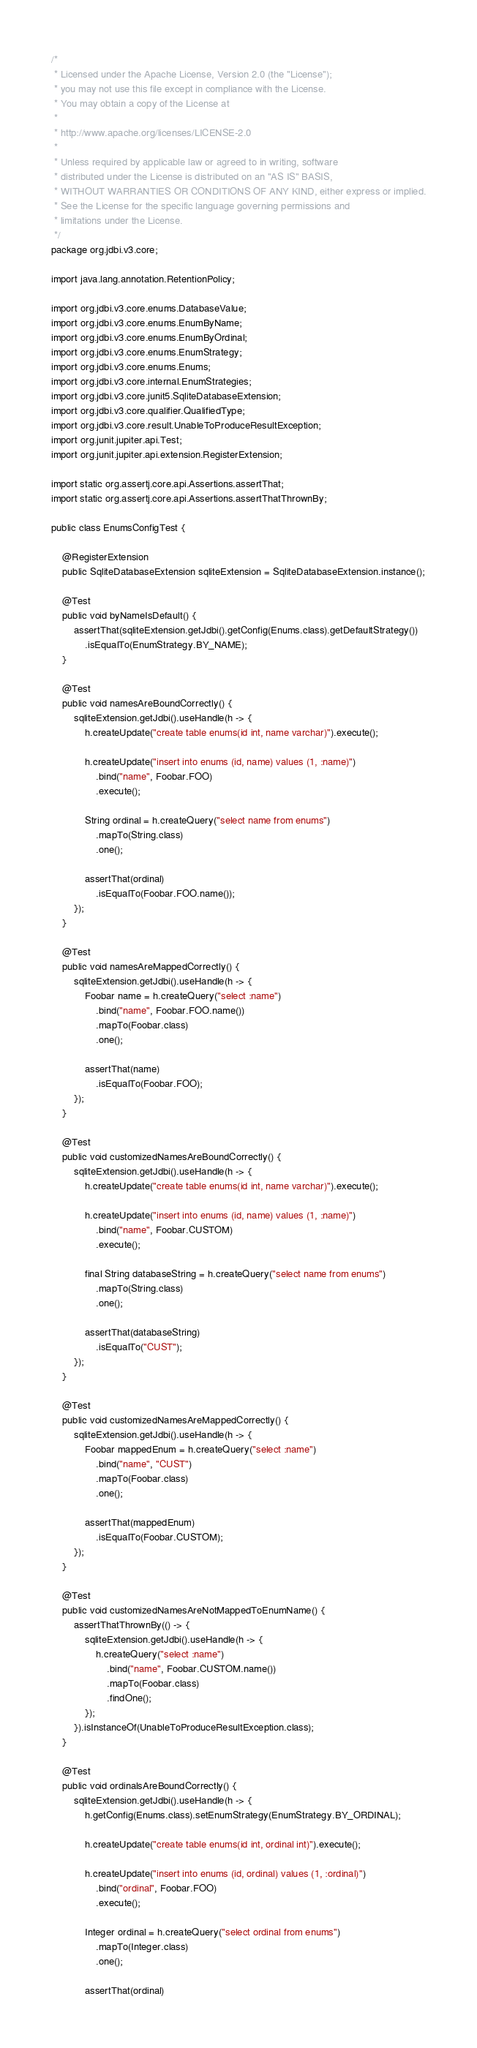<code> <loc_0><loc_0><loc_500><loc_500><_Java_>/*
 * Licensed under the Apache License, Version 2.0 (the "License");
 * you may not use this file except in compliance with the License.
 * You may obtain a copy of the License at
 *
 * http://www.apache.org/licenses/LICENSE-2.0
 *
 * Unless required by applicable law or agreed to in writing, software
 * distributed under the License is distributed on an "AS IS" BASIS,
 * WITHOUT WARRANTIES OR CONDITIONS OF ANY KIND, either express or implied.
 * See the License for the specific language governing permissions and
 * limitations under the License.
 */
package org.jdbi.v3.core;

import java.lang.annotation.RetentionPolicy;

import org.jdbi.v3.core.enums.DatabaseValue;
import org.jdbi.v3.core.enums.EnumByName;
import org.jdbi.v3.core.enums.EnumByOrdinal;
import org.jdbi.v3.core.enums.EnumStrategy;
import org.jdbi.v3.core.enums.Enums;
import org.jdbi.v3.core.internal.EnumStrategies;
import org.jdbi.v3.core.junit5.SqliteDatabaseExtension;
import org.jdbi.v3.core.qualifier.QualifiedType;
import org.jdbi.v3.core.result.UnableToProduceResultException;
import org.junit.jupiter.api.Test;
import org.junit.jupiter.api.extension.RegisterExtension;

import static org.assertj.core.api.Assertions.assertThat;
import static org.assertj.core.api.Assertions.assertThatThrownBy;

public class EnumsConfigTest {

    @RegisterExtension
    public SqliteDatabaseExtension sqliteExtension = SqliteDatabaseExtension.instance();

    @Test
    public void byNameIsDefault() {
        assertThat(sqliteExtension.getJdbi().getConfig(Enums.class).getDefaultStrategy())
            .isEqualTo(EnumStrategy.BY_NAME);
    }

    @Test
    public void namesAreBoundCorrectly() {
        sqliteExtension.getJdbi().useHandle(h -> {
            h.createUpdate("create table enums(id int, name varchar)").execute();

            h.createUpdate("insert into enums (id, name) values (1, :name)")
                .bind("name", Foobar.FOO)
                .execute();

            String ordinal = h.createQuery("select name from enums")
                .mapTo(String.class)
                .one();

            assertThat(ordinal)
                .isEqualTo(Foobar.FOO.name());
        });
    }

    @Test
    public void namesAreMappedCorrectly() {
        sqliteExtension.getJdbi().useHandle(h -> {
            Foobar name = h.createQuery("select :name")
                .bind("name", Foobar.FOO.name())
                .mapTo(Foobar.class)
                .one();

            assertThat(name)
                .isEqualTo(Foobar.FOO);
        });
    }

    @Test
    public void customizedNamesAreBoundCorrectly() {
        sqliteExtension.getJdbi().useHandle(h -> {
            h.createUpdate("create table enums(id int, name varchar)").execute();

            h.createUpdate("insert into enums (id, name) values (1, :name)")
                .bind("name", Foobar.CUSTOM)
                .execute();

            final String databaseString = h.createQuery("select name from enums")
                .mapTo(String.class)
                .one();

            assertThat(databaseString)
                .isEqualTo("CUST");
        });
    }

    @Test
    public void customizedNamesAreMappedCorrectly() {
        sqliteExtension.getJdbi().useHandle(h -> {
            Foobar mappedEnum = h.createQuery("select :name")
                .bind("name", "CUST")
                .mapTo(Foobar.class)
                .one();

            assertThat(mappedEnum)
                .isEqualTo(Foobar.CUSTOM);
        });
    }

    @Test
    public void customizedNamesAreNotMappedToEnumName() {
        assertThatThrownBy(() -> {
            sqliteExtension.getJdbi().useHandle(h -> {
                h.createQuery("select :name")
                    .bind("name", Foobar.CUSTOM.name())
                    .mapTo(Foobar.class)
                    .findOne();
            });
        }).isInstanceOf(UnableToProduceResultException.class);
    }

    @Test
    public void ordinalsAreBoundCorrectly() {
        sqliteExtension.getJdbi().useHandle(h -> {
            h.getConfig(Enums.class).setEnumStrategy(EnumStrategy.BY_ORDINAL);

            h.createUpdate("create table enums(id int, ordinal int)").execute();

            h.createUpdate("insert into enums (id, ordinal) values (1, :ordinal)")
                .bind("ordinal", Foobar.FOO)
                .execute();

            Integer ordinal = h.createQuery("select ordinal from enums")
                .mapTo(Integer.class)
                .one();

            assertThat(ordinal)</code> 